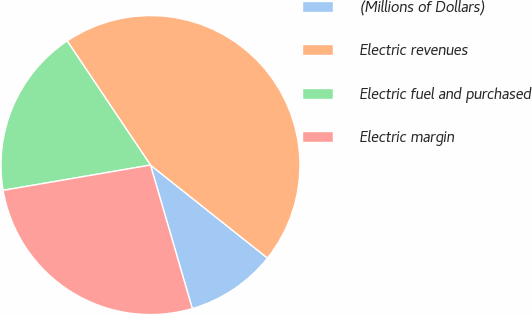Convert chart to OTSL. <chart><loc_0><loc_0><loc_500><loc_500><pie_chart><fcel>(Millions of Dollars)<fcel>Electric revenues<fcel>Electric fuel and purchased<fcel>Electric margin<nl><fcel>9.8%<fcel>45.1%<fcel>18.3%<fcel>26.81%<nl></chart> 